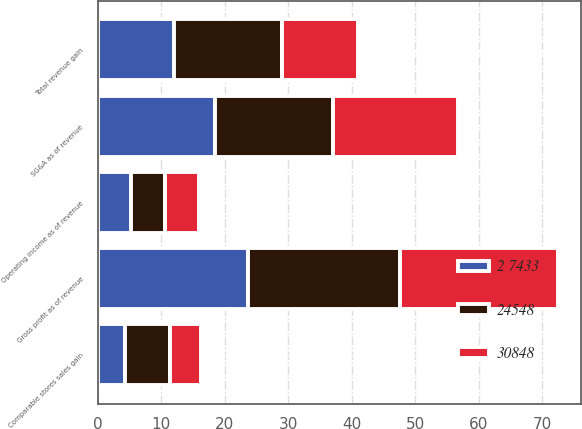Convert chart to OTSL. <chart><loc_0><loc_0><loc_500><loc_500><stacked_bar_chart><ecel><fcel>Total revenue gain<fcel>Comparable stores sales gain<fcel>Gross profit as of revenue<fcel>SG&A as of revenue<fcel>Operating income as of revenue<nl><fcel>30848<fcel>12<fcel>4.9<fcel>25<fcel>19.7<fcel>5.3<nl><fcel>2 7433<fcel>12<fcel>4.3<fcel>23.7<fcel>18.4<fcel>5.3<nl><fcel>24548<fcel>17<fcel>7.1<fcel>23.9<fcel>18.6<fcel>5.3<nl></chart> 